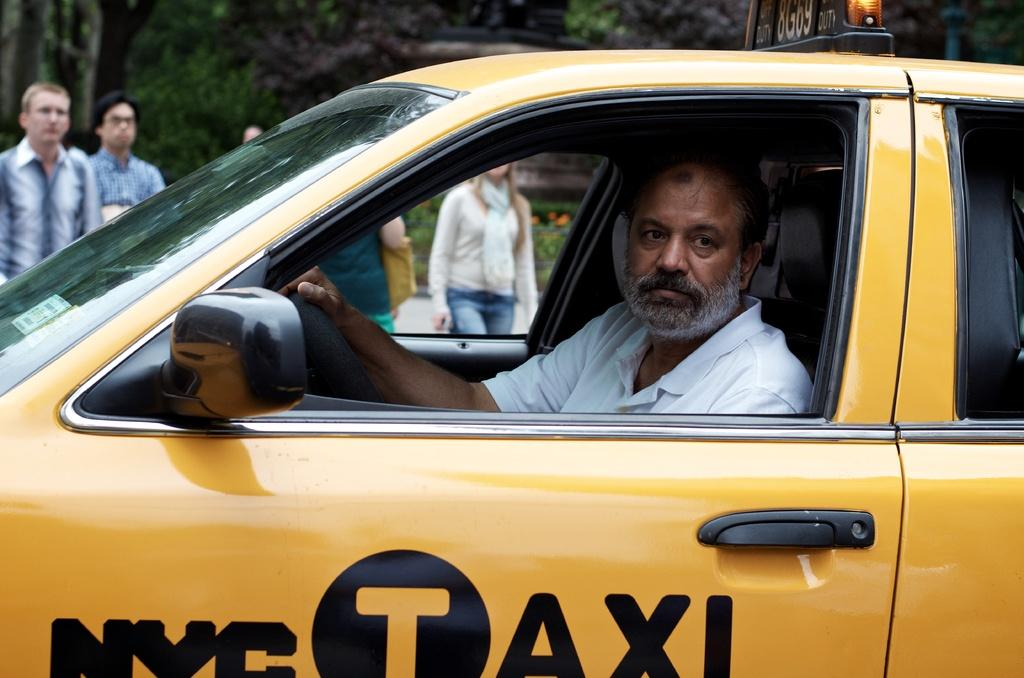<image>
Present a compact description of the photo's key features. Man looking on while sitting in his NYC TAXI. 